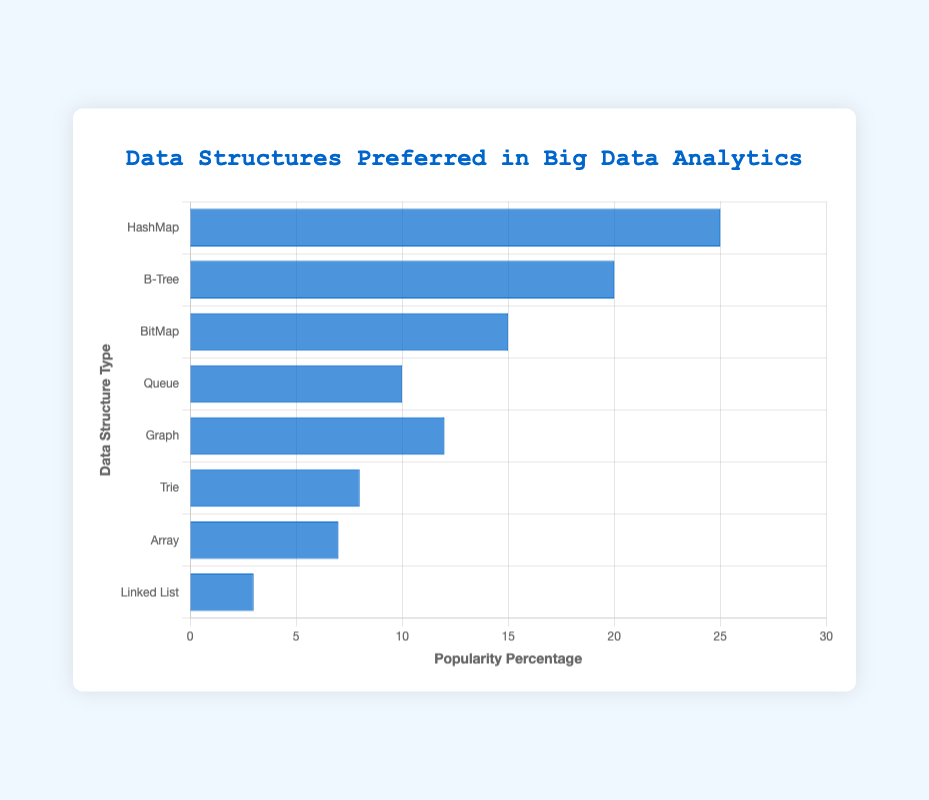Which data structure is the most popular in big data analytics tasks? The bar for HashMap reaches the highest value on the chart at 25%, indicating it is the most popular data structure.
Answer: HashMap Which data structure is less popular than Graph but more popular than Array? From the chart, Graph has a popularity of 12%, and Array has 7%. The bar for Trie is in between these values at 8%.
Answer: Trie Which two data structures combined just surpass the popularity of HashMap? Adding the percentages for B-Tree (20%) and Queue (10%) results in 30%, which is slightly higher than HashMap's 25%.
Answer: B-Tree and Queue By how much is BitMap more popular than Linked List? BitMap has a popularity of 15%, and Linked List has 3%. The difference is 15% - 3% = 12%.
Answer: 12% Rank the data structures from most to least popular. HashMap (25%), B-Tree (20%), BitMap (15%), Graph (12%), Queue (10%), Trie (8%), Array (7%), Linked List (3%).
Answer: 1) HashMap 2) B-Tree 3) BitMap 4) Graph 5) Queue 6) Trie 7) Array 8) Linked List Which data structures have a popularity percentage above 10%? The bars for HashMap (25%), B-Tree (20%), BitMap (15%), and Graph (12%) all extend above the 10% mark.
Answer: HashMap, B-Tree, BitMap, Graph What is the average popularity percentage of all data structures? Sum of percentages: 25% + 20% + 15% + 10% + 12% + 8% + 7% + 3% = 100%. There are 8 data structures, so the average is 100% / 8 = 12.5%.
Answer: 12.5% What is the combined popularity of BitMap, Queue, and Graph? Adding the percentages for BitMap (15%), Queue (10%), and Graph (12%) results in 15% + 10% + 12% = 37%.
Answer: 37% Which data structure has the second-lowest popularity? Arranging the data, Linked List (3%) has the lowest, and Array (7%) is the second lowest.
Answer: Array Which data structures each have a single-digit percentage popularity? The data structures with bars in the single-digit range are Trie (8%), Array (7%), and Linked List (3%).
Answer: Trie, Array, Linked List 